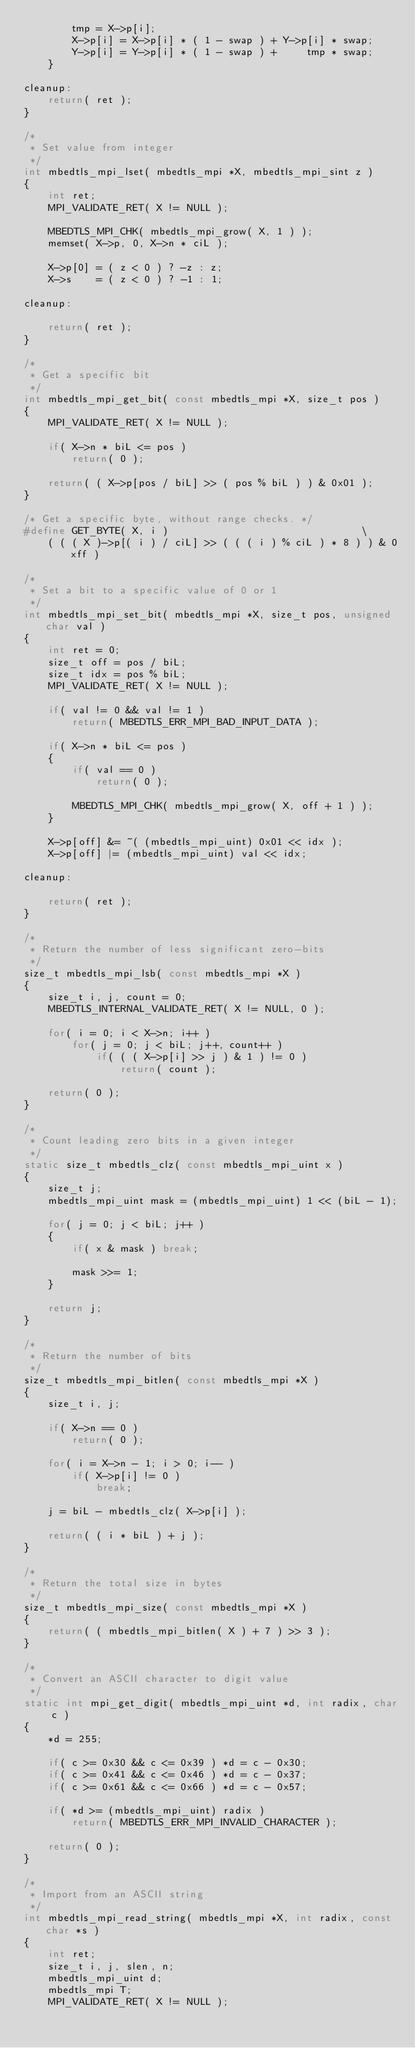<code> <loc_0><loc_0><loc_500><loc_500><_C_>        tmp = X->p[i];
        X->p[i] = X->p[i] * ( 1 - swap ) + Y->p[i] * swap;
        Y->p[i] = Y->p[i] * ( 1 - swap ) +     tmp * swap;
    }

cleanup:
    return( ret );
}

/*
 * Set value from integer
 */
int mbedtls_mpi_lset( mbedtls_mpi *X, mbedtls_mpi_sint z )
{
    int ret;
    MPI_VALIDATE_RET( X != NULL );

    MBEDTLS_MPI_CHK( mbedtls_mpi_grow( X, 1 ) );
    memset( X->p, 0, X->n * ciL );

    X->p[0] = ( z < 0 ) ? -z : z;
    X->s    = ( z < 0 ) ? -1 : 1;

cleanup:

    return( ret );
}

/*
 * Get a specific bit
 */
int mbedtls_mpi_get_bit( const mbedtls_mpi *X, size_t pos )
{
    MPI_VALIDATE_RET( X != NULL );

    if( X->n * biL <= pos )
        return( 0 );

    return( ( X->p[pos / biL] >> ( pos % biL ) ) & 0x01 );
}

/* Get a specific byte, without range checks. */
#define GET_BYTE( X, i )                                \
    ( ( ( X )->p[( i ) / ciL] >> ( ( ( i ) % ciL ) * 8 ) ) & 0xff )

/*
 * Set a bit to a specific value of 0 or 1
 */
int mbedtls_mpi_set_bit( mbedtls_mpi *X, size_t pos, unsigned char val )
{
    int ret = 0;
    size_t off = pos / biL;
    size_t idx = pos % biL;
    MPI_VALIDATE_RET( X != NULL );

    if( val != 0 && val != 1 )
        return( MBEDTLS_ERR_MPI_BAD_INPUT_DATA );

    if( X->n * biL <= pos )
    {
        if( val == 0 )
            return( 0 );

        MBEDTLS_MPI_CHK( mbedtls_mpi_grow( X, off + 1 ) );
    }

    X->p[off] &= ~( (mbedtls_mpi_uint) 0x01 << idx );
    X->p[off] |= (mbedtls_mpi_uint) val << idx;

cleanup:

    return( ret );
}

/*
 * Return the number of less significant zero-bits
 */
size_t mbedtls_mpi_lsb( const mbedtls_mpi *X )
{
    size_t i, j, count = 0;
    MBEDTLS_INTERNAL_VALIDATE_RET( X != NULL, 0 );

    for( i = 0; i < X->n; i++ )
        for( j = 0; j < biL; j++, count++ )
            if( ( ( X->p[i] >> j ) & 1 ) != 0 )
                return( count );

    return( 0 );
}

/*
 * Count leading zero bits in a given integer
 */
static size_t mbedtls_clz( const mbedtls_mpi_uint x )
{
    size_t j;
    mbedtls_mpi_uint mask = (mbedtls_mpi_uint) 1 << (biL - 1);

    for( j = 0; j < biL; j++ )
    {
        if( x & mask ) break;

        mask >>= 1;
    }

    return j;
}

/*
 * Return the number of bits
 */
size_t mbedtls_mpi_bitlen( const mbedtls_mpi *X )
{
    size_t i, j;

    if( X->n == 0 )
        return( 0 );

    for( i = X->n - 1; i > 0; i-- )
        if( X->p[i] != 0 )
            break;

    j = biL - mbedtls_clz( X->p[i] );

    return( ( i * biL ) + j );
}

/*
 * Return the total size in bytes
 */
size_t mbedtls_mpi_size( const mbedtls_mpi *X )
{
    return( ( mbedtls_mpi_bitlen( X ) + 7 ) >> 3 );
}

/*
 * Convert an ASCII character to digit value
 */
static int mpi_get_digit( mbedtls_mpi_uint *d, int radix, char c )
{
    *d = 255;

    if( c >= 0x30 && c <= 0x39 ) *d = c - 0x30;
    if( c >= 0x41 && c <= 0x46 ) *d = c - 0x37;
    if( c >= 0x61 && c <= 0x66 ) *d = c - 0x57;

    if( *d >= (mbedtls_mpi_uint) radix )
        return( MBEDTLS_ERR_MPI_INVALID_CHARACTER );

    return( 0 );
}

/*
 * Import from an ASCII string
 */
int mbedtls_mpi_read_string( mbedtls_mpi *X, int radix, const char *s )
{
    int ret;
    size_t i, j, slen, n;
    mbedtls_mpi_uint d;
    mbedtls_mpi T;
    MPI_VALIDATE_RET( X != NULL );</code> 